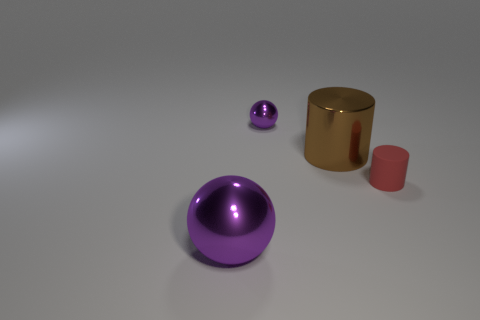What is the material of the tiny red cylinder?
Keep it short and to the point. Rubber. Are there any matte cylinders?
Your answer should be compact. Yes. What is the color of the big thing behind the large metallic sphere?
Ensure brevity in your answer.  Brown. There is a big metal thing to the right of the sphere that is behind the red cylinder; how many purple metal balls are on the right side of it?
Offer a very short reply. 0. What is the thing that is in front of the large brown shiny object and behind the large ball made of?
Provide a short and direct response. Rubber. Is the big ball made of the same material as the object behind the big brown shiny cylinder?
Keep it short and to the point. Yes. Are there more large cylinders right of the tiny rubber object than large brown shiny cylinders that are left of the large brown metal thing?
Ensure brevity in your answer.  No. The tiny purple thing is what shape?
Make the answer very short. Sphere. Are the purple thing behind the large shiny ball and the purple thing in front of the large brown metallic cylinder made of the same material?
Make the answer very short. Yes. There is a tiny object behind the small red rubber thing; what shape is it?
Provide a short and direct response. Sphere. 